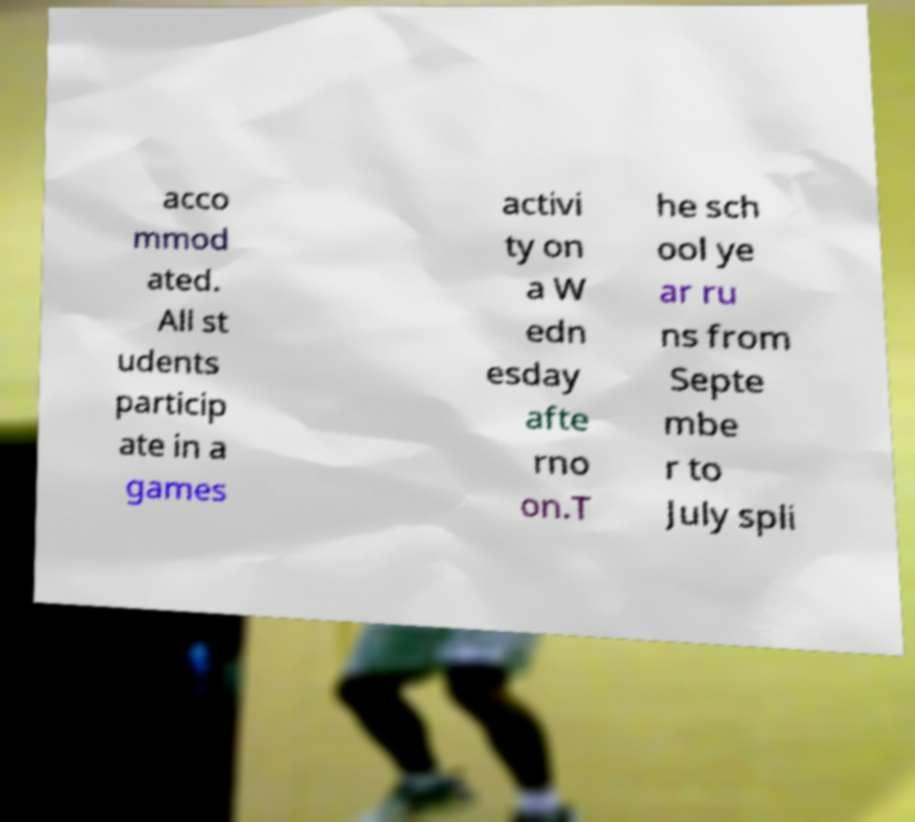Could you extract and type out the text from this image? acco mmod ated. All st udents particip ate in a games activi ty on a W edn esday afte rno on.T he sch ool ye ar ru ns from Septe mbe r to July spli 